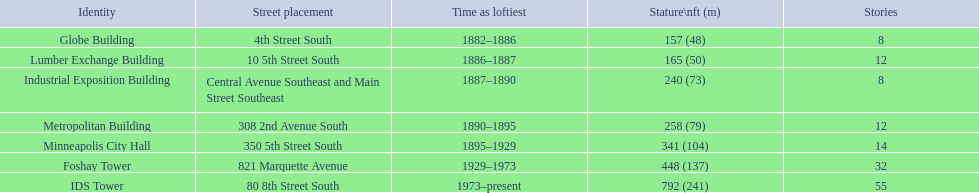How many floors does the globe building have? 8. Which building has 14 floors? Minneapolis City Hall. The lumber exchange building has the same number of floors as which building? Metropolitan Building. 